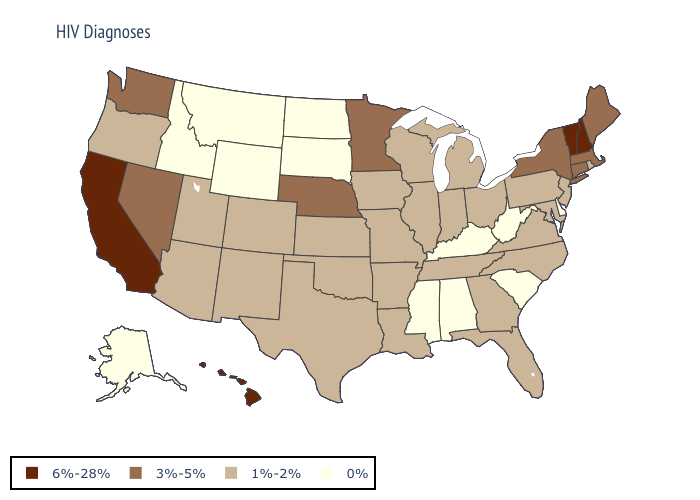Does Georgia have a higher value than Alabama?
Quick response, please. Yes. Does New Jersey have the lowest value in the Northeast?
Give a very brief answer. Yes. Does Nevada have the same value as Maine?
Short answer required. Yes. Among the states that border Louisiana , which have the highest value?
Write a very short answer. Arkansas, Texas. Which states have the lowest value in the Northeast?
Write a very short answer. New Jersey, Pennsylvania, Rhode Island. Does New Hampshire have the highest value in the USA?
Concise answer only. Yes. What is the lowest value in the South?
Keep it brief. 0%. What is the lowest value in the West?
Quick response, please. 0%. What is the value of Kansas?
Answer briefly. 1%-2%. Among the states that border Louisiana , does Texas have the lowest value?
Be succinct. No. What is the value of Michigan?
Keep it brief. 1%-2%. Among the states that border North Carolina , which have the highest value?
Write a very short answer. Georgia, Tennessee, Virginia. Name the states that have a value in the range 0%?
Concise answer only. Alabama, Alaska, Delaware, Idaho, Kentucky, Mississippi, Montana, North Dakota, South Carolina, South Dakota, West Virginia, Wyoming. Which states have the lowest value in the USA?
Short answer required. Alabama, Alaska, Delaware, Idaho, Kentucky, Mississippi, Montana, North Dakota, South Carolina, South Dakota, West Virginia, Wyoming. Among the states that border Connecticut , does Massachusetts have the highest value?
Give a very brief answer. Yes. 